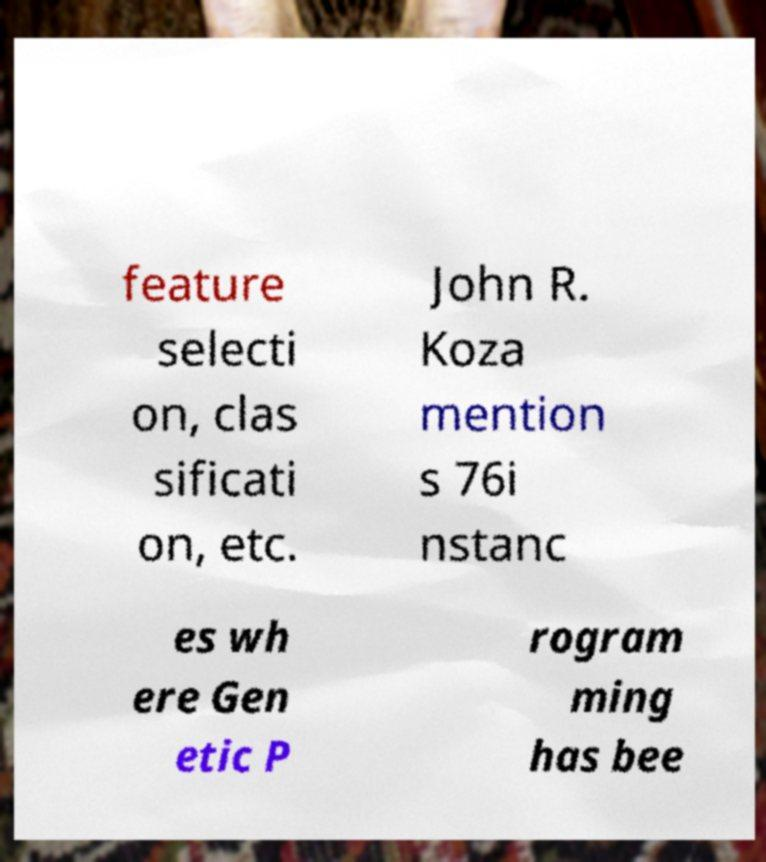Could you extract and type out the text from this image? feature selecti on, clas sificati on, etc. John R. Koza mention s 76i nstanc es wh ere Gen etic P rogram ming has bee 